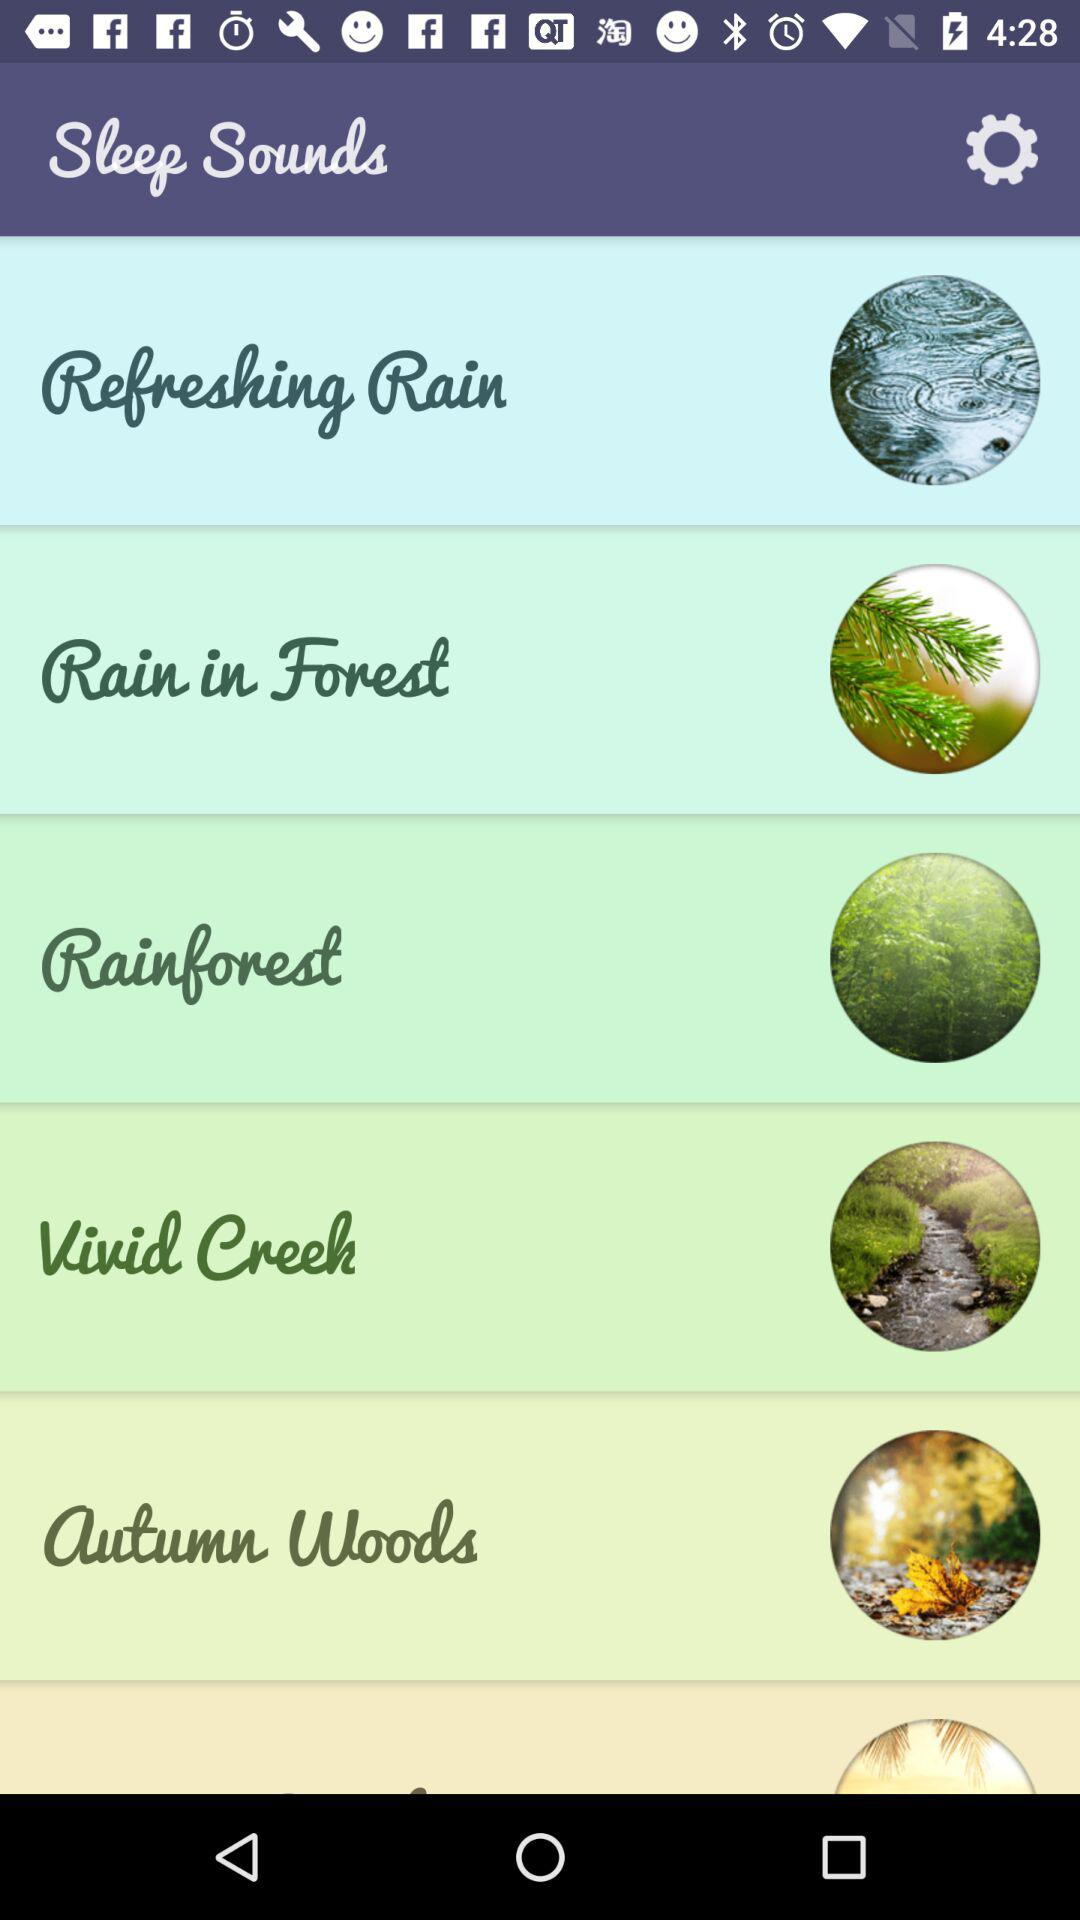Which version of the application is this?
When the provided information is insufficient, respond with <no answer>. <no answer> 